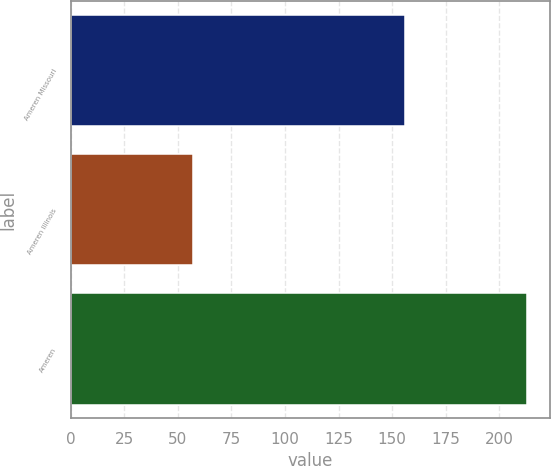Convert chart. <chart><loc_0><loc_0><loc_500><loc_500><bar_chart><fcel>Ameren Missouri<fcel>Ameren Illinois<fcel>Ameren<nl><fcel>156<fcel>57<fcel>213<nl></chart> 